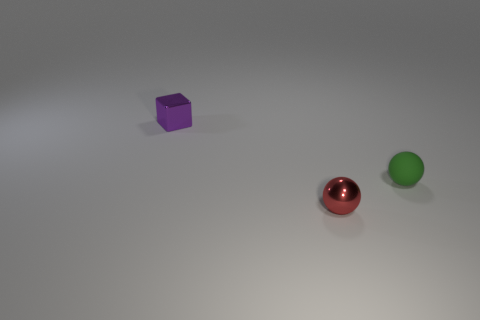What is the size of the red ball that is made of the same material as the purple cube?
Ensure brevity in your answer.  Small. How many other objects have the same shape as the green matte thing?
Give a very brief answer. 1. Is there any other thing that has the same size as the purple thing?
Provide a succinct answer. Yes. There is a metal thing that is right of the small thing on the left side of the tiny red sphere; how big is it?
Give a very brief answer. Small. What is the material of the red object that is the same size as the purple shiny cube?
Provide a succinct answer. Metal. Is there a brown object that has the same material as the red object?
Provide a short and direct response. No. There is a tiny sphere on the left side of the tiny green sphere on the right side of the tiny metal thing that is to the right of the block; what is its color?
Offer a very short reply. Red. Is the color of the tiny metallic object that is behind the matte ball the same as the metal object on the right side of the small purple shiny thing?
Your answer should be very brief. No. Is there any other thing of the same color as the rubber thing?
Provide a succinct answer. No. Is the number of red metal balls on the right side of the tiny green matte object less than the number of cyan shiny balls?
Your answer should be compact. No. 